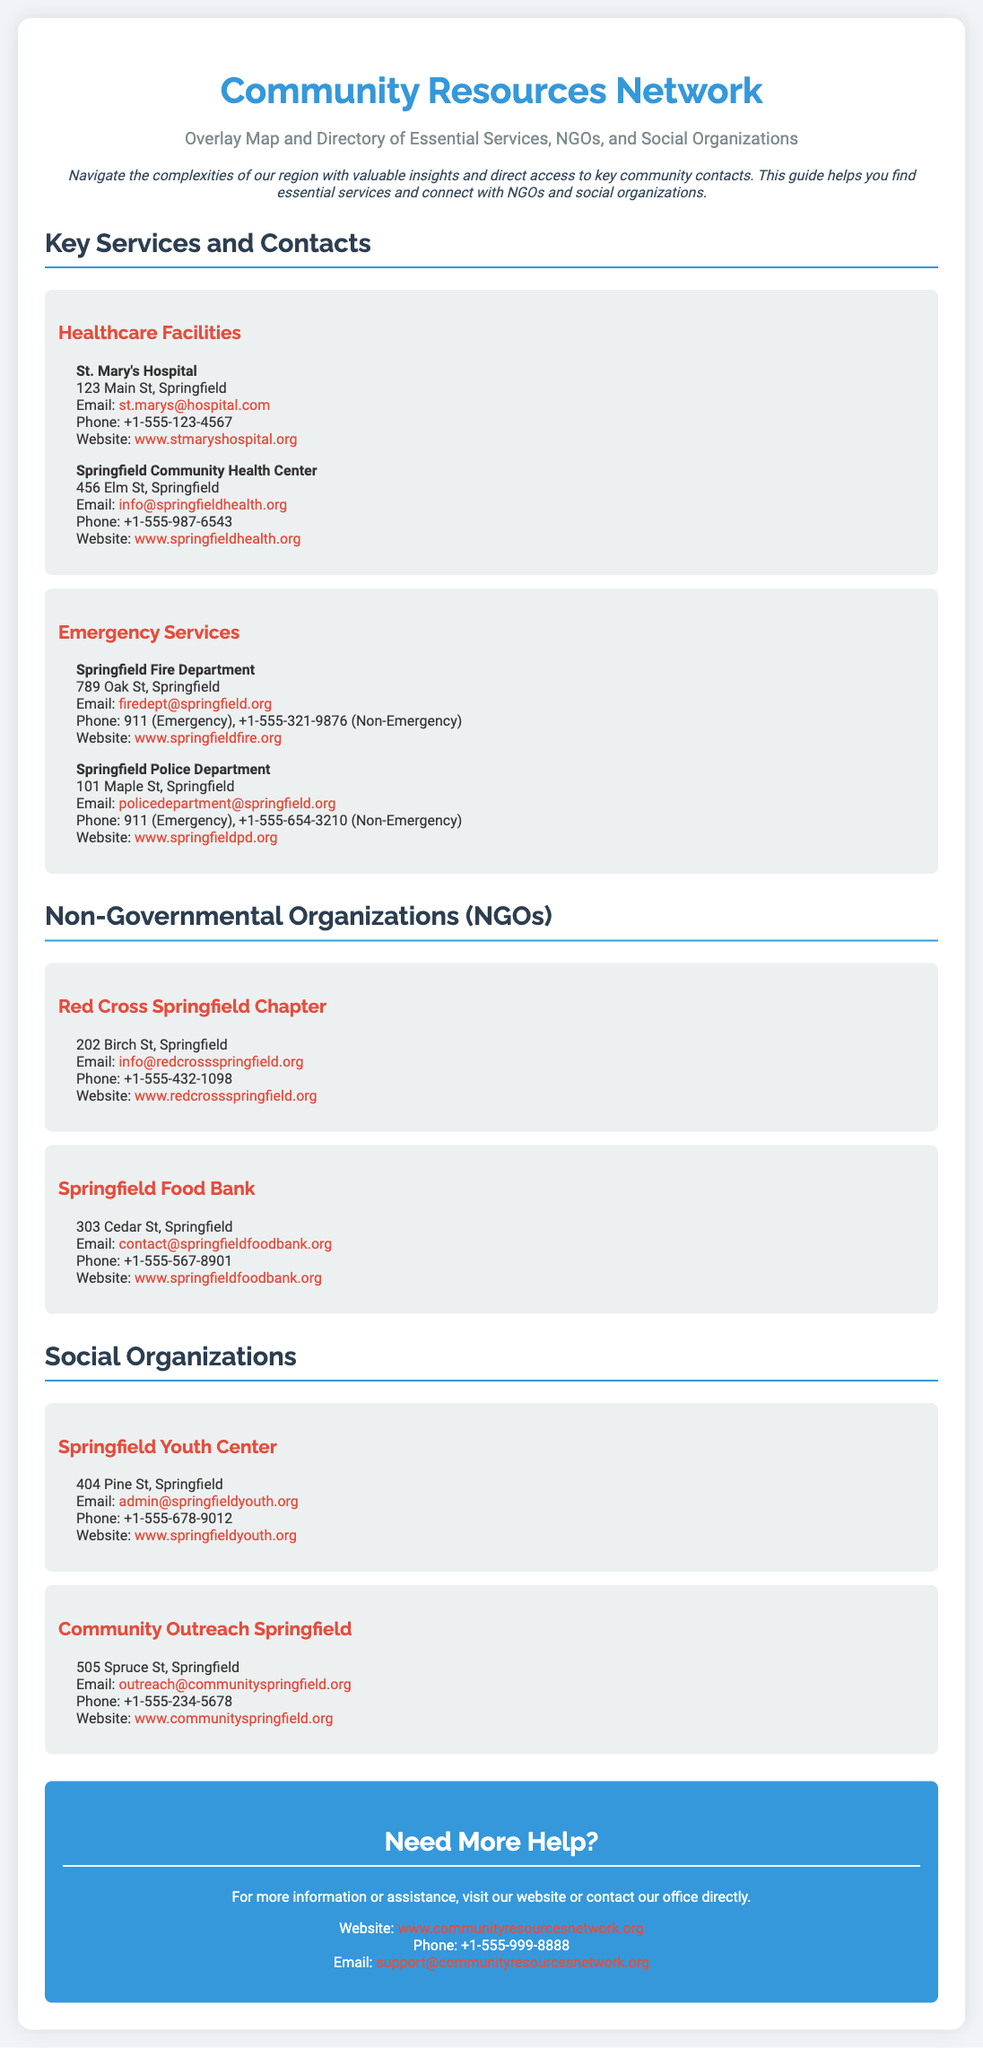what is the name of the healthcare facility located at 123 Main St, Springfield? The document lists St. Mary's Hospital as the healthcare facility at this address.
Answer: St. Mary's Hospital what is the email address for the Springfield Fire Department? The document contains the email address for the Springfield Fire Department, which is firedept@springfield.org.
Answer: firedept@springfield.org how many phone numbers are provided for the Springfield Police Department? The document lists two phone numbers for the Springfield Police Department: one for emergency and one non-emergency.
Answer: 2 what is the address of the Springfield Food Bank? The document lists the address of the Springfield Food Bank as 303 Cedar St, Springfield.
Answer: 303 Cedar St, Springfield which organization has its location at 404 Pine St, Springfield? The document states that the Springfield Youth Center is located at this address.
Answer: Springfield Youth Center how can one contact the Community Resources Network for assistance? The document provides multiple methods to contact the Community Resources Network, including email, website, and phone.
Answer: Email, website, phone which color is used for the contact information section background? The contact information section has a background color of #3498db, which corresponds to a shade of blue.
Answer: Blue who is the intended audience for this poster? The poster is designed to help local residents navigate community resources and essential services.
Answer: Local residents what is the overarching purpose of the document? The document aims to provide access to essential services and connect individuals with NGOs and social organizations.
Answer: Provide access to essential services 